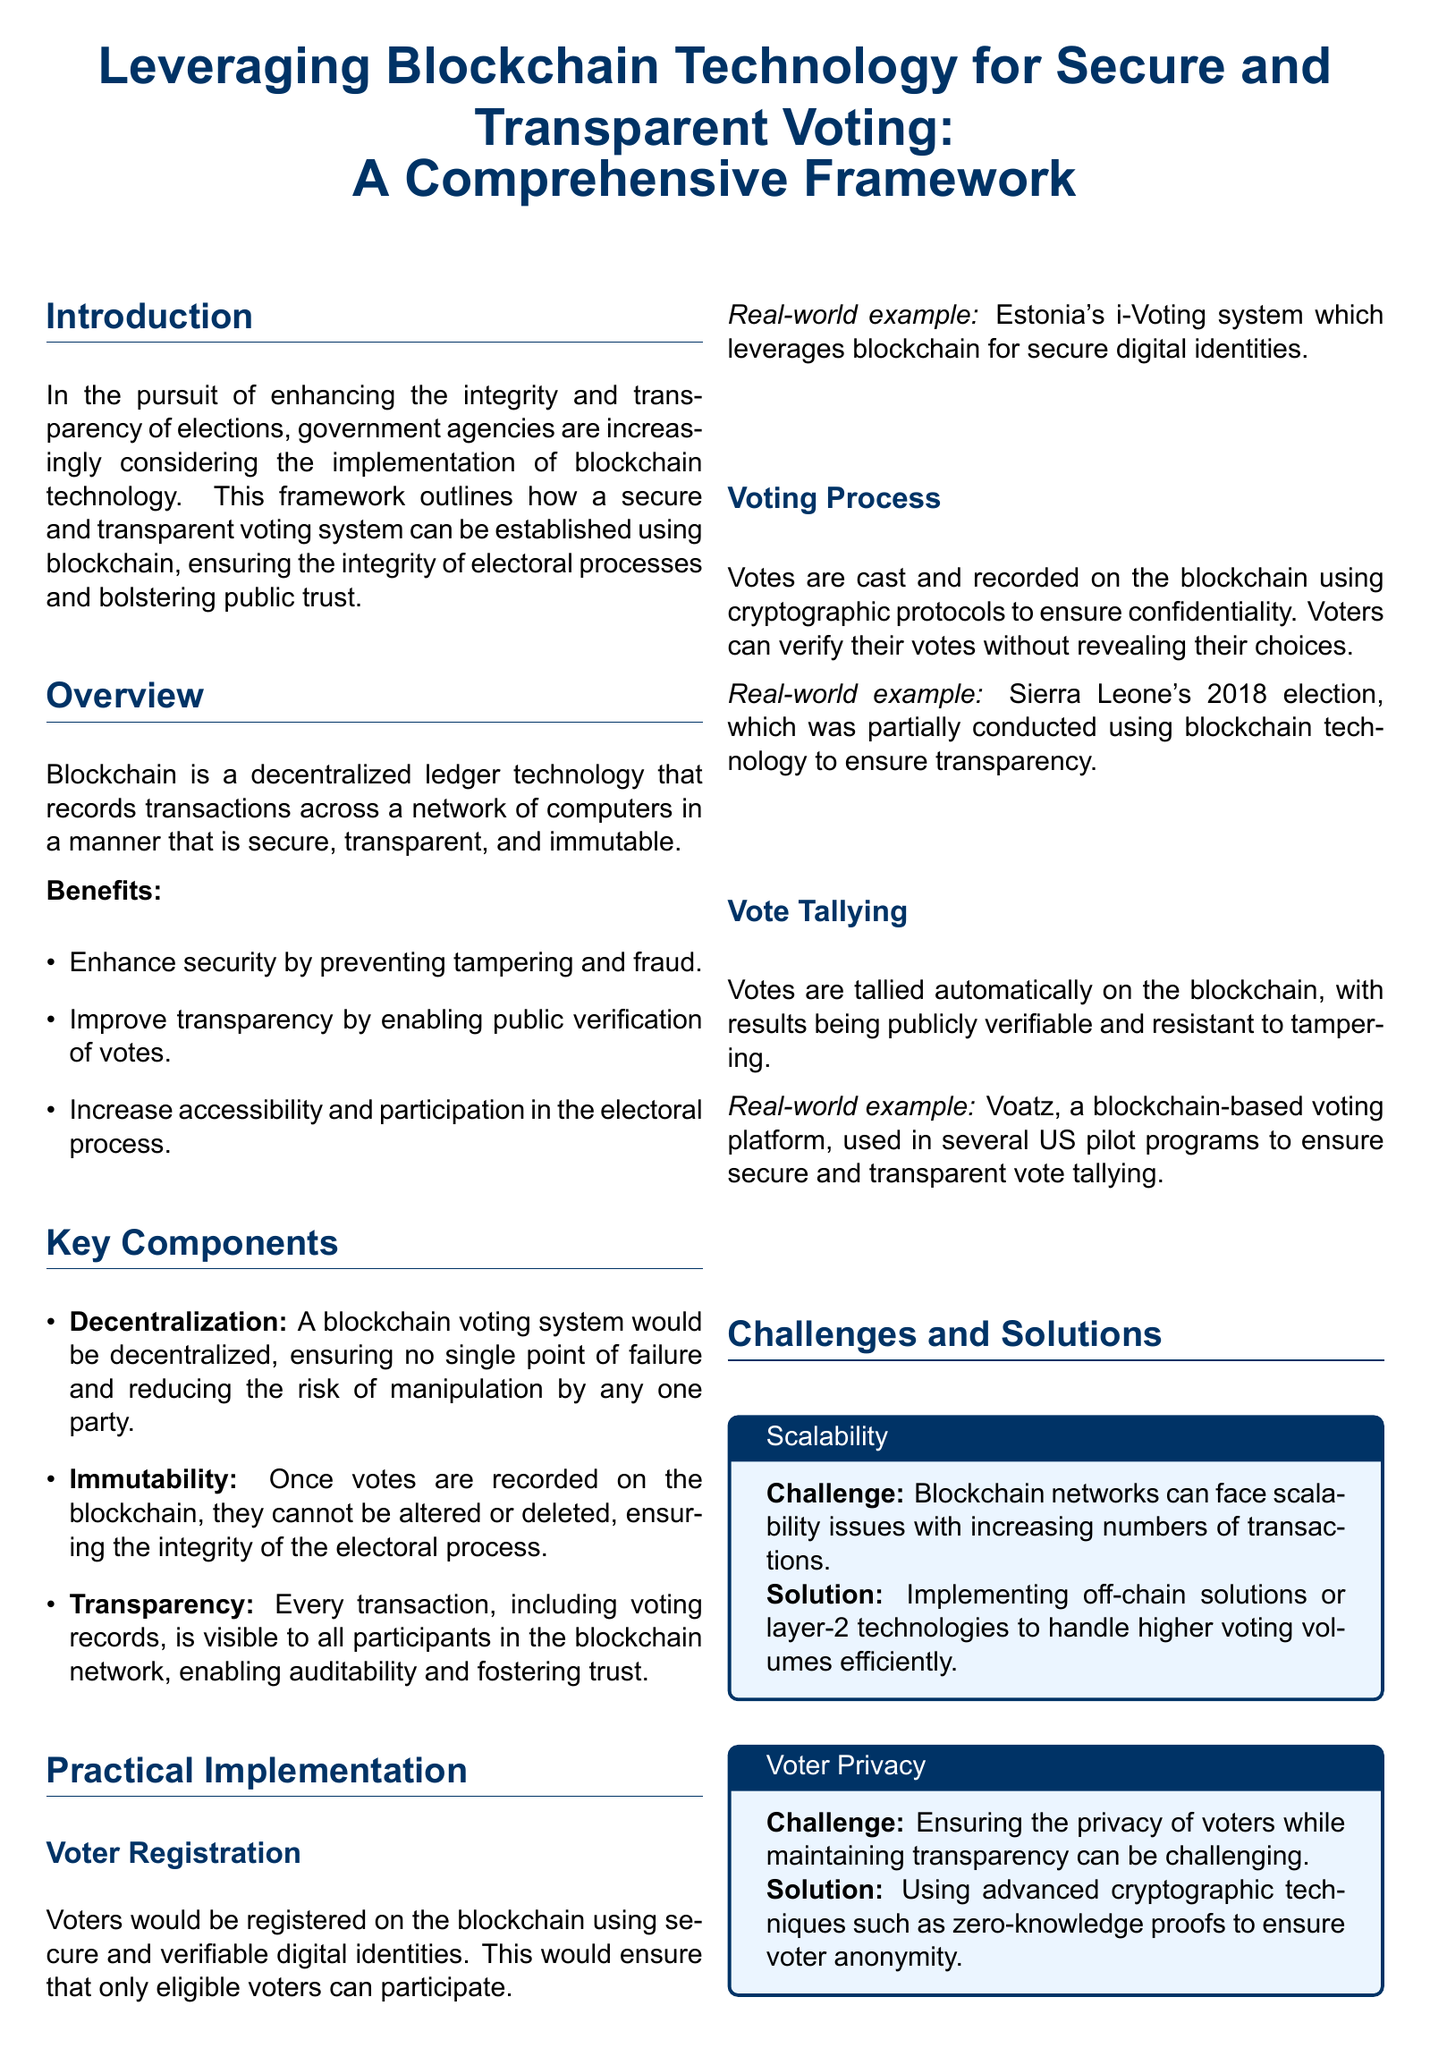What is the color code for government blue? The document specifies the RGB color code for government blue as a specific combination of red, green, and blue values.
Answer: 0,51,102 What technology is discussed for enhancing election integrity? The document outlines a technology that creates a decentralized, secure, and transparent system for voting processes.
Answer: Blockchain What type of identities will voters use for registration? The document mentions a specific method for registering voters that ensures eligibility and security.
Answer: Digital identities What real-world example is provided for voter registration? The document references a specific country's approach to secure digital identities in their voting system.
Answer: Estonia's i-Voting What is one challenge regarding voter privacy mentioned? The document highlights a concern related to maintaining voter anonymity while ensuring the openness of the voting process.
Answer: Voter Privacy What advanced technique is suggested to ensure voter anonymity? The document proposes a cryptographic approach to safeguard the confidentiality of voter choices.
Answer: Zero-knowledge proofs How many main components of the blockchain voting system are listed? The document enumerates distinct elements that are critical to the structure and functionality of the voting system.
Answer: Three What solution is provided for scalability issues in blockchain networks? The document suggests a specific approach for coping with the high transaction volumes in voting scenarios.
Answer: Off-chain solutions What is a real-world example of using blockchain for vote tallying? The document cites a specific platform that was employed in pilot programs to secure vote counting procedures.
Answer: Voatz 